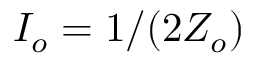<formula> <loc_0><loc_0><loc_500><loc_500>I _ { o } = 1 / ( 2 Z _ { o } )</formula> 